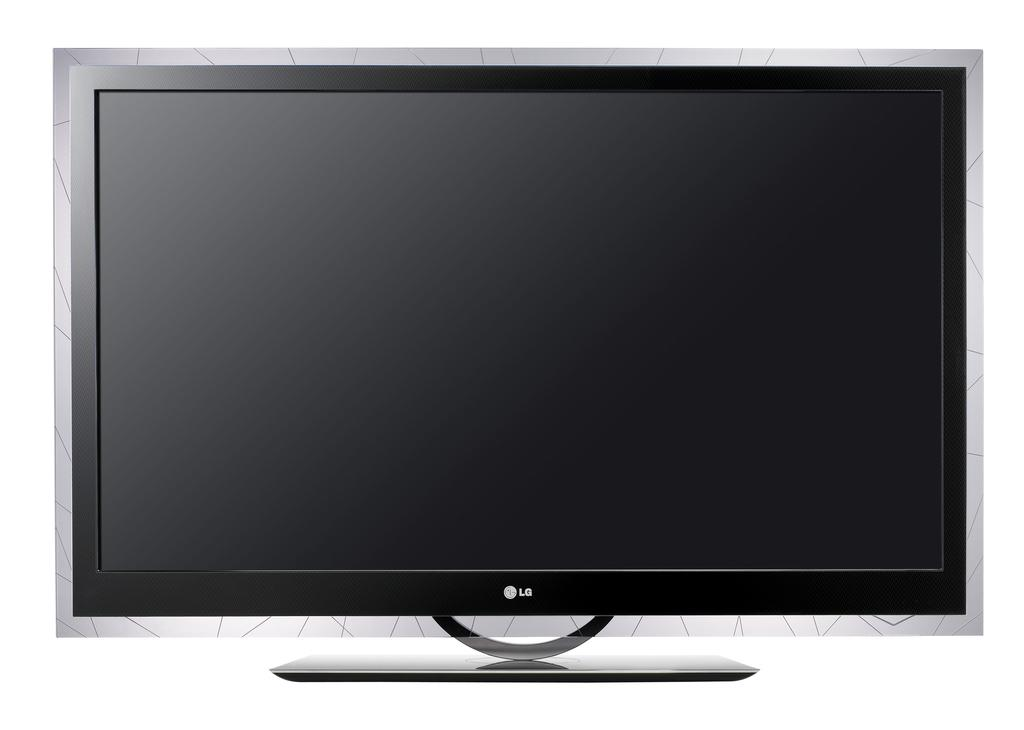What type of television is visible in the image? There is an LG television in the image. What color is the background of the image? The background of the image is white. How is the television being used in the image? The image does not show the television being used, so it cannot be determined from the image. 